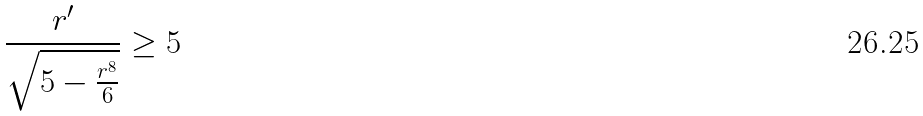Convert formula to latex. <formula><loc_0><loc_0><loc_500><loc_500>\frac { r ^ { \prime } } { \sqrt { 5 - \frac { r ^ { 8 } } { 6 } } } \geq 5</formula> 